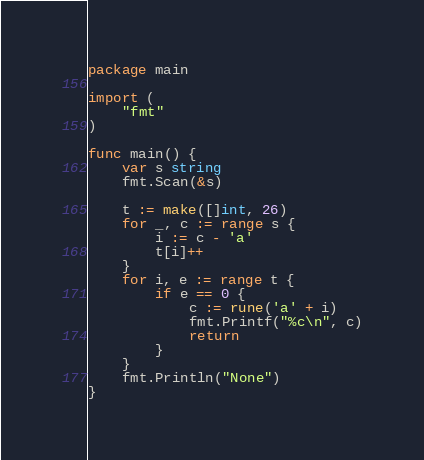<code> <loc_0><loc_0><loc_500><loc_500><_Go_>package main

import (
	"fmt"
)

func main() {
	var s string
	fmt.Scan(&s)

	t := make([]int, 26)
	for _, c := range s {
		i := c - 'a'
		t[i]++
	}
	for i, e := range t {
		if e == 0 {
			c := rune('a' + i)
			fmt.Printf("%c\n", c)
			return
		}
	}
	fmt.Println("None")
}
</code> 